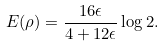Convert formula to latex. <formula><loc_0><loc_0><loc_500><loc_500>E ( \rho ) = \frac { 1 6 \epsilon } { 4 + 1 2 \epsilon } \log 2 .</formula> 